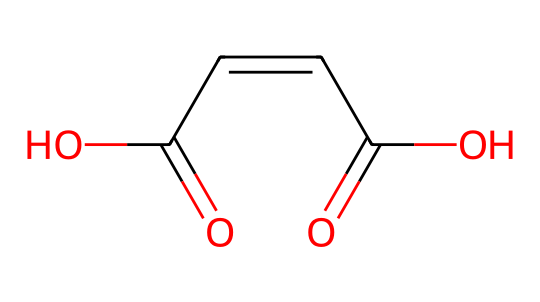What is the molecular formula of maleic acid? To determine the molecular formula, count all the atoms represented in the SMILES. There are 4 carbons (C), 4 oxygens (O), and 4 hydrogens (H), hence the formula is C4H4O4.
Answer: C4H4O4 How many double bonds are present in maleic acid? The SMILES notation shows two carbon-carbon (C=C) double bonds within the structure, representing the presence of 1 double bond between C1 and C2 and another one between C2 and C3. Therefore, there is one C=C double bond.
Answer: 1 What type of isomerism is exhibited by maleic acid? Maleic acid exhibits geometric (cis-trans) isomerism due to the presence of the double bond between carbons. This configuration allows for different spatial arrangements of the groups attached to the double-bonded carbons.
Answer: geometric isomerism How many unique geometric isomers can maleic acid have? In geometric isomerism, if there are substituents that differ on either side of a double bond, two distinct geometric isomers (cis and trans) can form. Since maleic acid has such substituents, it can exist as two unique geometric isomers.
Answer: 2 What structural feature differentiates maleic acid from fumaric acid? The key structural difference is based on the orientation of the carboxylic acid groups (COOH). Maleic acid has both COOH groups on the same side (cis), while fumaric acid has them on opposite sides (trans). This difference in configuration leads to different properties.
Answer: cis and trans What is the relevance of geometric isomerism in biodegradable plastics? Geometric isomerism can influence the physical properties and reactivity of the compounds used in biodegradable plastics, impacting their degradation rates and environmental sustainability.
Answer: physical properties and reactivity 